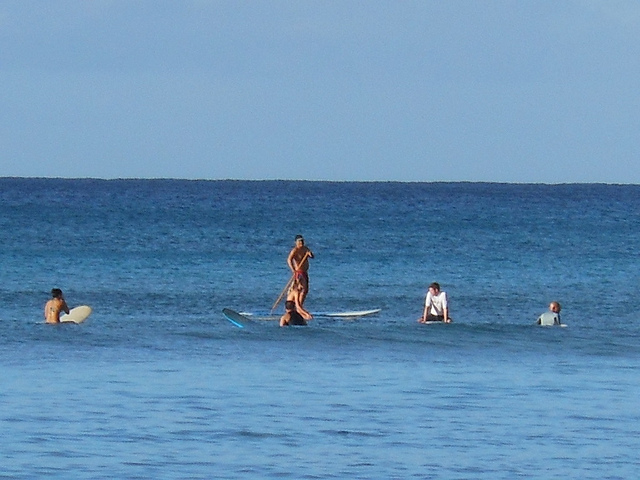Can you describe the environment where these water activities are taking place? Absolutely! The image showcases a serene ocean setting with a calm sea that is ideal for stand-up paddleboarding and learning to surf. The blue skies suggest that it is a clear day, which is perfect for outdoor activities. The location is likely to be a beach favored for water sports due to the gentle waves and open space, allowing enthusiasts of all levels to participate in their activities safely. 